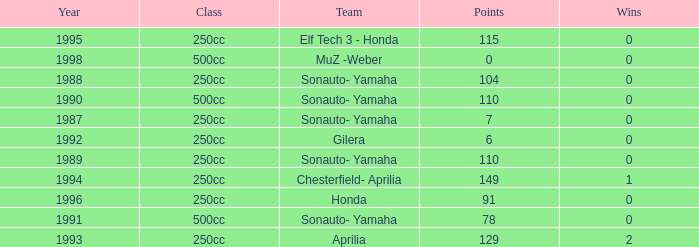How many wins did the team, which had more than 110 points, have in 1989? None. 